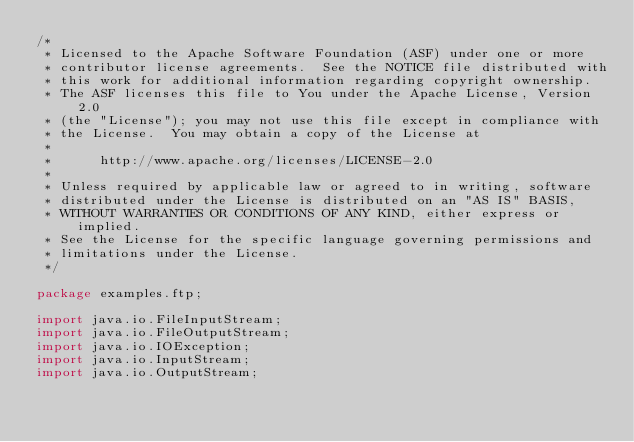<code> <loc_0><loc_0><loc_500><loc_500><_Java_>/*
 * Licensed to the Apache Software Foundation (ASF) under one or more
 * contributor license agreements.  See the NOTICE file distributed with
 * this work for additional information regarding copyright ownership.
 * The ASF licenses this file to You under the Apache License, Version 2.0
 * (the "License"); you may not use this file except in compliance with
 * the License.  You may obtain a copy of the License at
 *
 *      http://www.apache.org/licenses/LICENSE-2.0
 *
 * Unless required by applicable law or agreed to in writing, software
 * distributed under the License is distributed on an "AS IS" BASIS,
 * WITHOUT WARRANTIES OR CONDITIONS OF ANY KIND, either express or implied.
 * See the License for the specific language governing permissions and
 * limitations under the License.
 */

package examples.ftp;

import java.io.FileInputStream;
import java.io.FileOutputStream;
import java.io.IOException;
import java.io.InputStream;
import java.io.OutputStream;</code> 